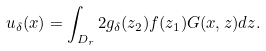Convert formula to latex. <formula><loc_0><loc_0><loc_500><loc_500>u _ { \delta } ( x ) = \int _ { D _ { r } } 2 g _ { \delta } ( z _ { 2 } ) f ( z _ { 1 } ) G ( x , z ) d z .</formula> 